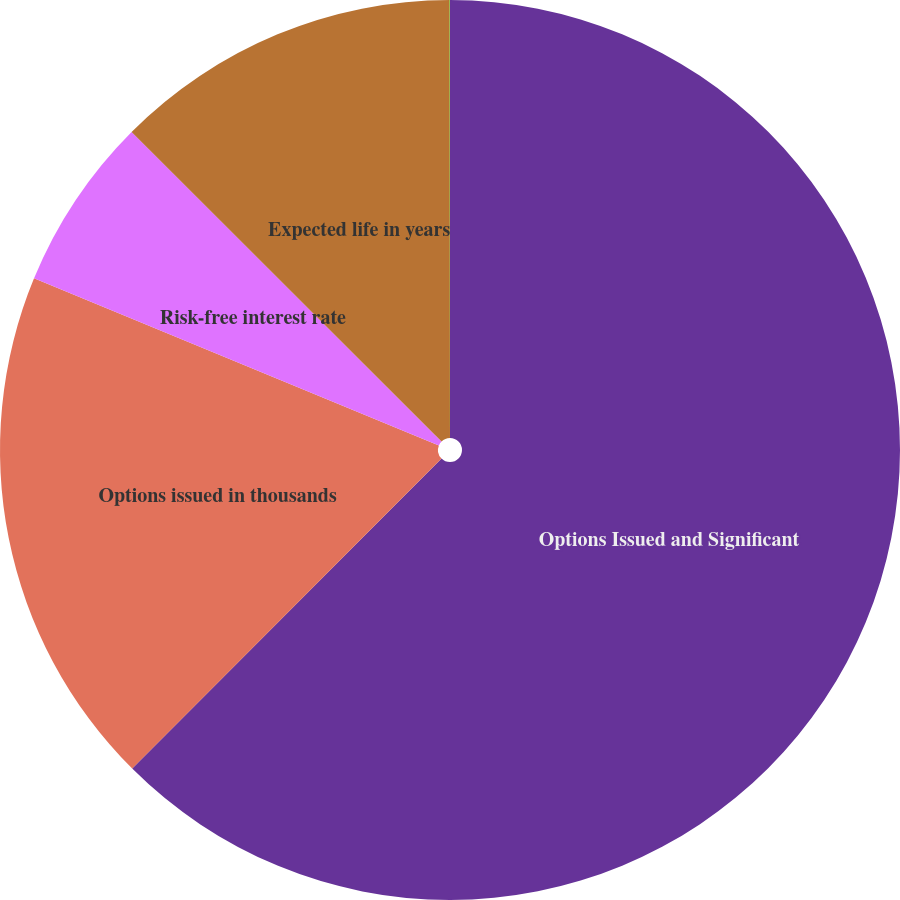Convert chart. <chart><loc_0><loc_0><loc_500><loc_500><pie_chart><fcel>Options Issued and Significant<fcel>Options issued in thousands<fcel>Risk-free interest rate<fcel>Expected life in years<fcel>Expected volatility<nl><fcel>62.48%<fcel>18.75%<fcel>6.26%<fcel>12.5%<fcel>0.01%<nl></chart> 